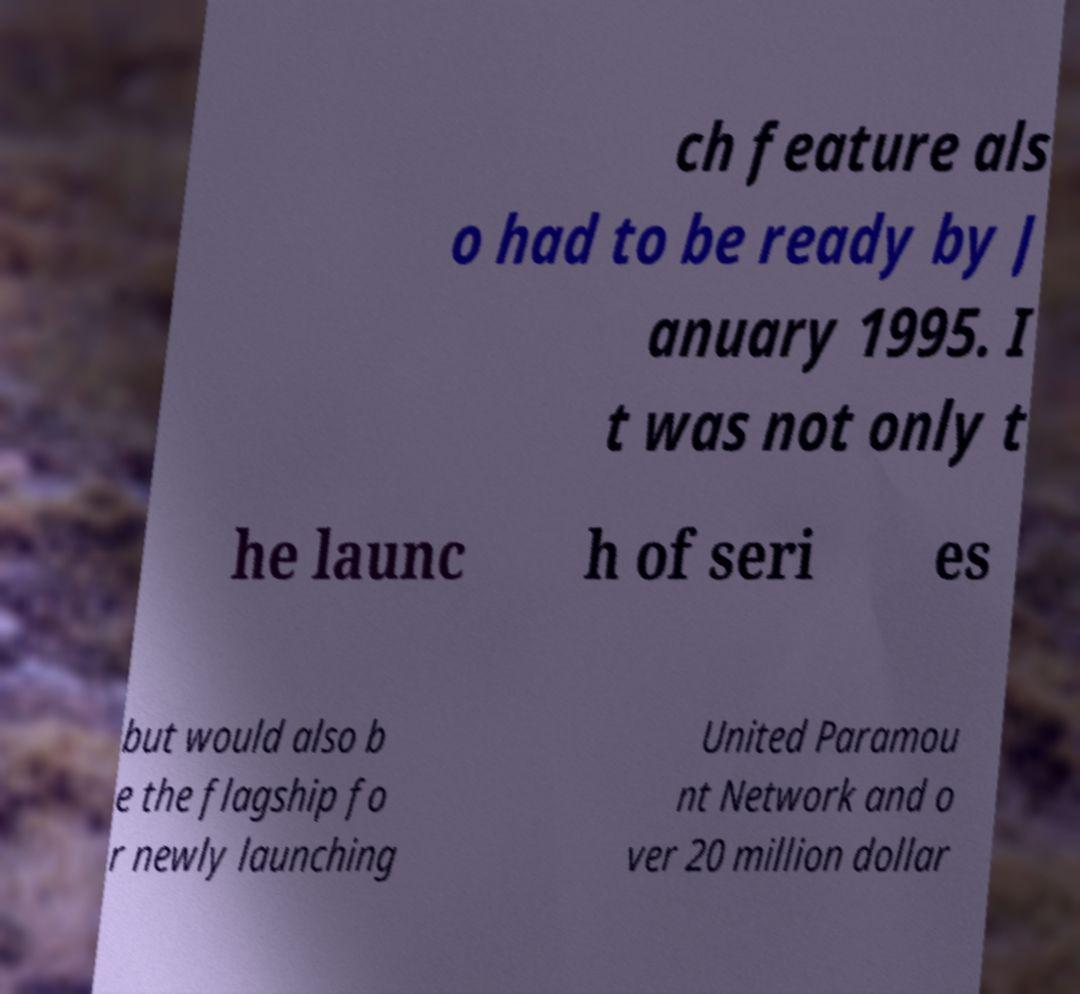Could you assist in decoding the text presented in this image and type it out clearly? ch feature als o had to be ready by J anuary 1995. I t was not only t he launc h of seri es but would also b e the flagship fo r newly launching United Paramou nt Network and o ver 20 million dollar 